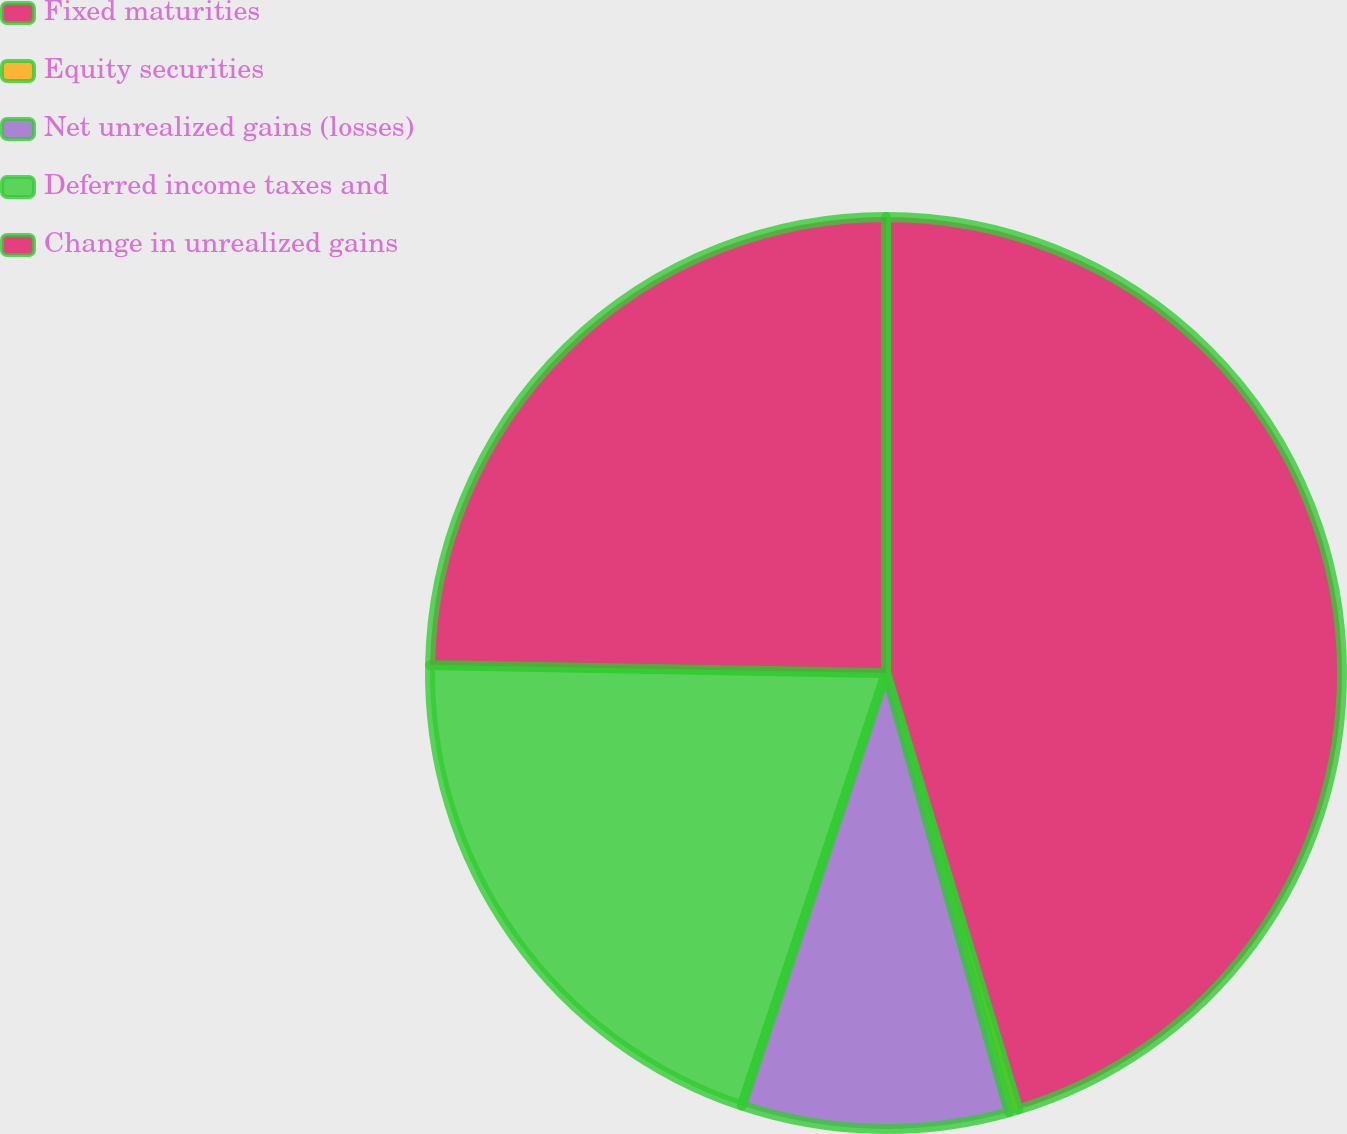<chart> <loc_0><loc_0><loc_500><loc_500><pie_chart><fcel>Fixed maturities<fcel>Equity securities<fcel>Net unrealized gains (losses)<fcel>Deferred income taxes and<fcel>Change in unrealized gains<nl><fcel>45.32%<fcel>0.33%<fcel>9.47%<fcel>20.16%<fcel>24.72%<nl></chart> 